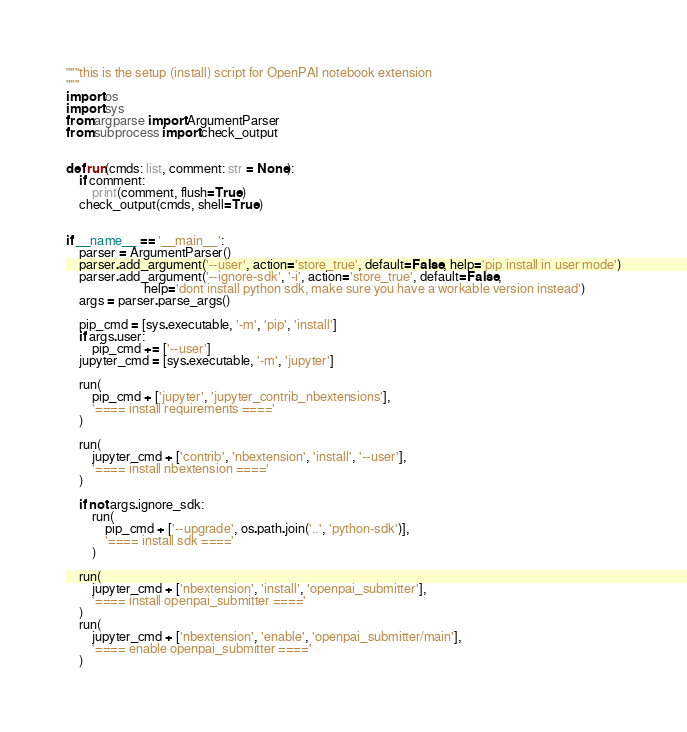<code> <loc_0><loc_0><loc_500><loc_500><_Python_>"""this is the setup (install) script for OpenPAI notebook extension
"""
import os
import sys
from argparse import ArgumentParser
from subprocess import check_output


def run(cmds: list, comment: str = None):
    if comment:
        print(comment, flush=True)
    check_output(cmds, shell=True)


if __name__ == '__main__':
    parser = ArgumentParser()
    parser.add_argument('--user', action='store_true', default=False, help='pip install in user mode')
    parser.add_argument('--ignore-sdk', '-i', action='store_true', default=False,
                        help='dont install python sdk, make sure you have a workable version instead')
    args = parser.parse_args()

    pip_cmd = [sys.executable, '-m', 'pip', 'install']
    if args.user:
        pip_cmd += ['--user']
    jupyter_cmd = [sys.executable, '-m', 'jupyter']

    run(
        pip_cmd + ['jupyter', 'jupyter_contrib_nbextensions'],
        '==== install requirements ===='
    )

    run(
        jupyter_cmd + ['contrib', 'nbextension', 'install', '--user'],
        '==== install nbextension ===='
    )

    if not args.ignore_sdk:
        run(
            pip_cmd + ['--upgrade', os.path.join('..', 'python-sdk')],
            '==== install sdk ===='
        )

    run(
        jupyter_cmd + ['nbextension', 'install', 'openpai_submitter'],
        '==== install openpai_submitter ===='
    )
    run(
        jupyter_cmd + ['nbextension', 'enable', 'openpai_submitter/main'],
        '==== enable openpai_submitter ===='
    )
</code> 